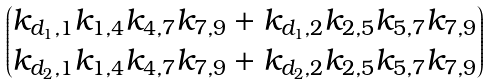<formula> <loc_0><loc_0><loc_500><loc_500>\begin{pmatrix} k _ { d _ { 1 } , 1 } k _ { 1 , 4 } k _ { 4 , 7 } k _ { 7 , 9 } + k _ { d _ { 1 } , 2 } k _ { 2 , 5 } k _ { 5 , 7 } k _ { 7 , 9 } \\ k _ { d _ { 2 } , 1 } k _ { 1 , 4 } k _ { 4 , 7 } k _ { 7 , 9 } + k _ { d _ { 2 } , 2 } k _ { 2 , 5 } k _ { 5 , 7 } k _ { 7 , 9 } \end{pmatrix}</formula> 